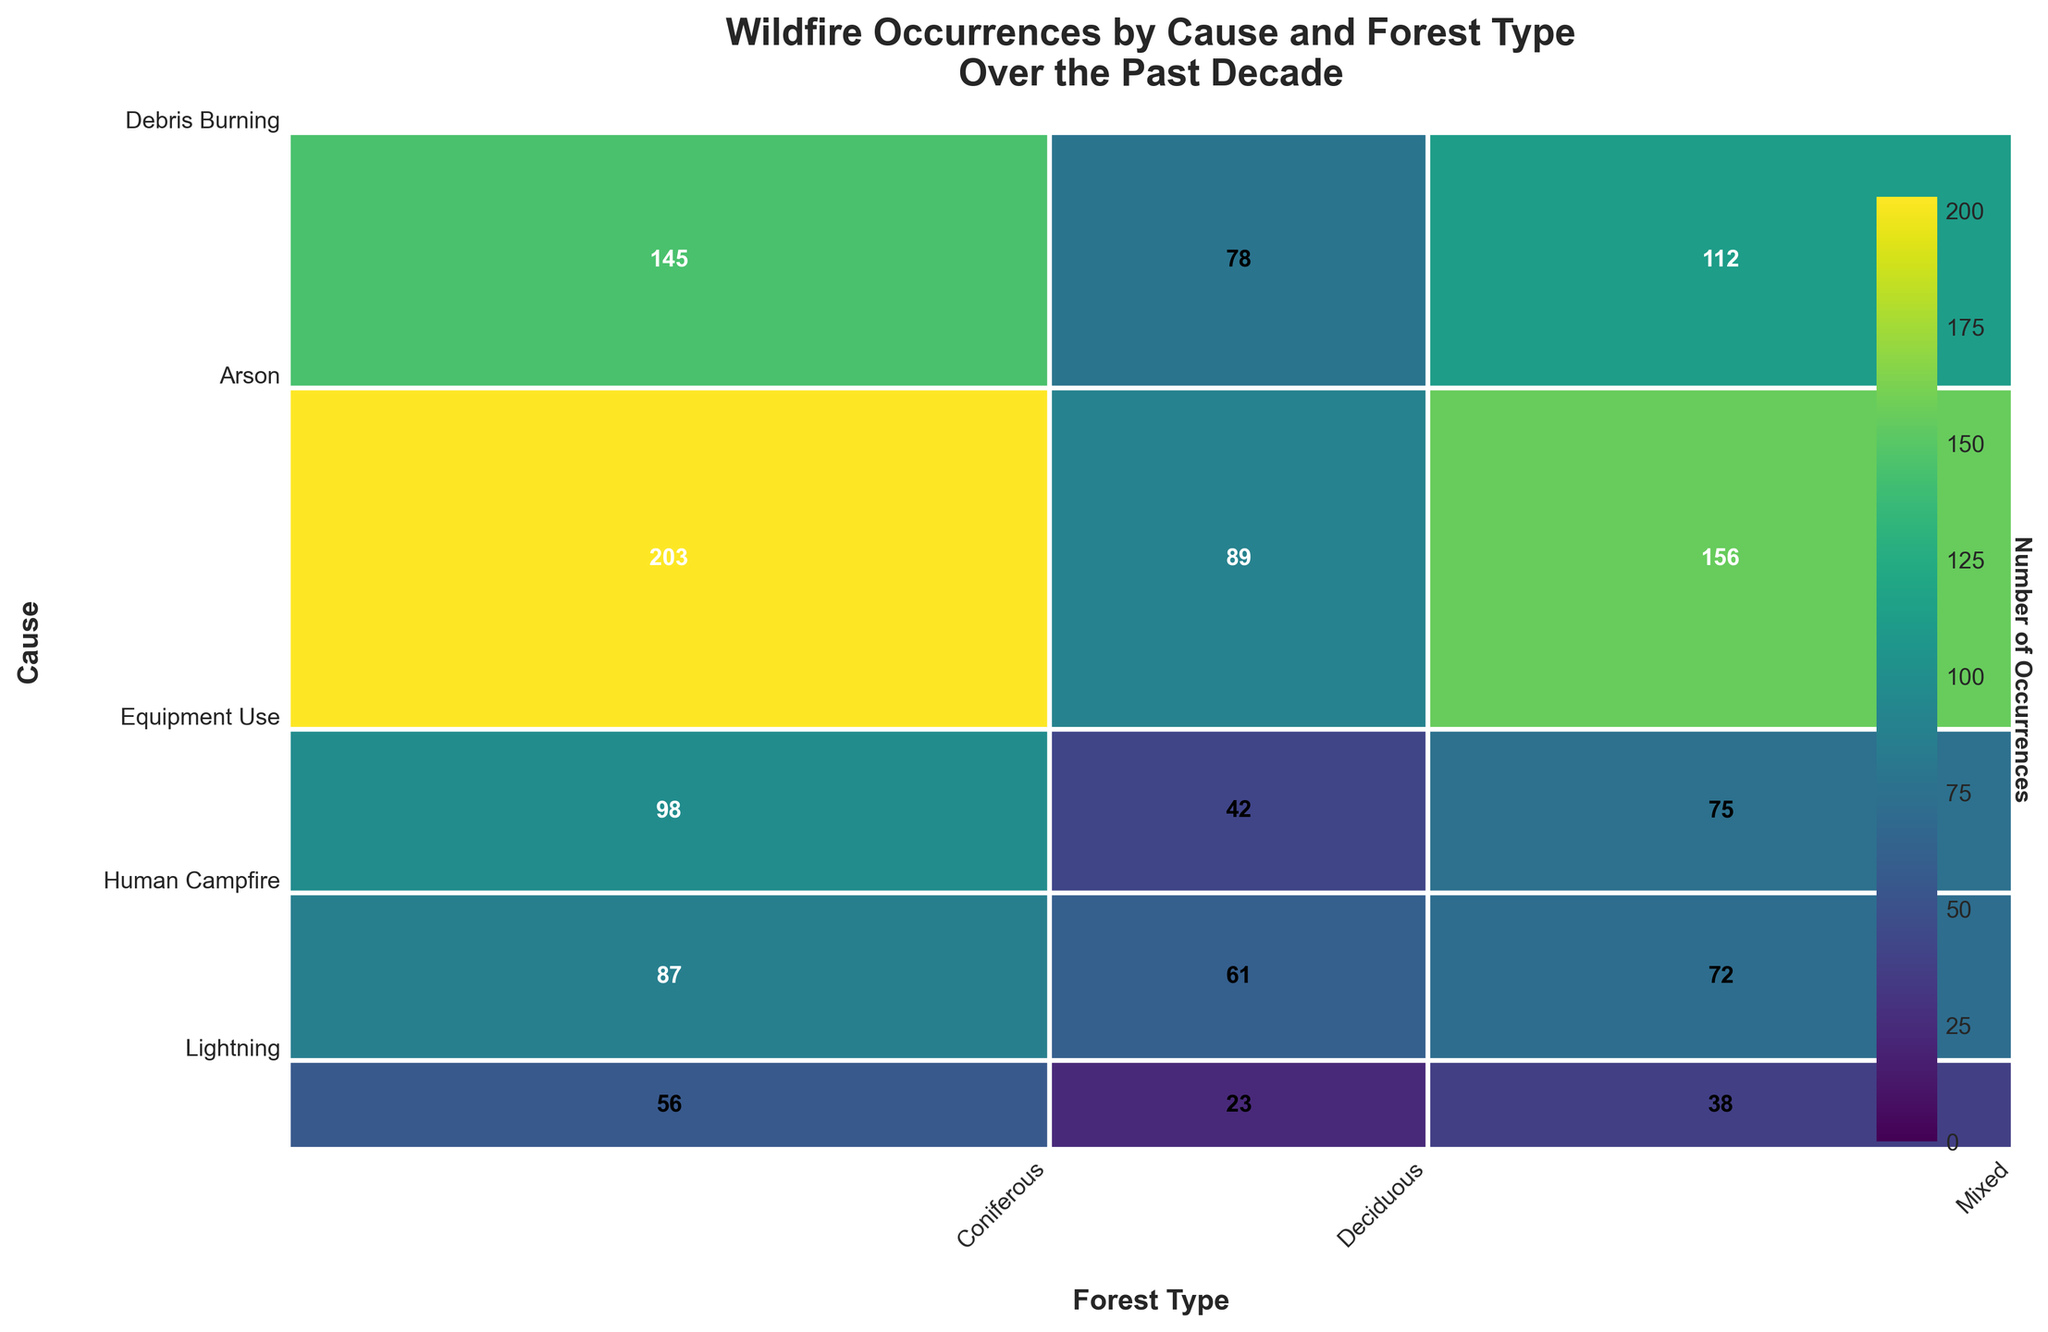Which forest type has the highest number of wildfire occurrences caused by Human Campfires? Look at the section corresponding to Human Campfires on the y-axis and identify which forest type (Coniferous, Deciduous, Mixed) has the largest area. The Coniferous forest type has the highest number of occurrences in this section.
Answer: Coniferous What is the total number of wildfire occurrences in Deciduous forests? Sum the occurrences of all causes (Lightning, Human Campfire, Equipment Use, Arson, Debris Burning) for Deciduous forests. 78 (Lightning) + 89 (Human Campfire) + 42 (Equipment Use) + 23 (Arson) + 61 (Debris Burning) = 293.
Answer: 293 Which wildfire cause has the least occurrences in Mixed forests? Identify the sections corresponding to Mixed forests for each cause on the y-axis and compare their areas. The smallest section corresponds to Arson with 38 occurrences.
Answer: Arson What is the proportion of Equipment Use-caused wildfires in Coniferous forests versus Mixed forests? Calculate the number of Equipment Use-caused wildfires in Coniferous and Mixed forests: 98 in Coniferous, 75 in Mixed. Proportion = 98 / (98 + 75).
Answer: 98 / (98 + 75) How many more wildfire occurrences are there in Coniferous forests due to Human Campfires compared to Debris Burning? Subtract the number of Debris Burning occurrences from Human Campfires in Coniferous forests: 203 (Human Campfire) - 87 (Debris Burning) = 116.
Answer: 116 Which forest type has the greatest total number of wildfires from all causes combined? Sum the occurrences for all forest types across all causes and compare: 
- Coniferous: 145 + 203 + 98 + 56 + 87 = 589
- Deciduous: 78 + 89 + 42 + 23 + 61 = 293
- Mixed: 112 + 156 + 75 + 38 + 72 = 453. Coniferous has the highest total.
Answer: Coniferous What's the average number of wildfires per cause in Mixed forests? Sum the occurrences for each cause in Mixed forests and divide by the number of causes: (Lightning 112 + Human Campfire 156 + Equipment Use 75 + Arson 38 + Debris Burning 72) / 5 = 453 / 5 = 90.6.
Answer: 90.6 What percentage of total wildfires are caused by Lightning in Coniferous forests? Find the total number of wildfires, then calculate the percentage of Lightning-caused in Coniferous forests: 
Total wildfires: 589 (Coniferous) + 293 (Deciduous) + 453 (Mixed) = 1335. 
Percentage = (145 / 1335) * 100 ≈ 10.9%.
Answer: 10.9% Which forest type has the smallest number of wildfires caused by Arson combined? Sum the occurrences of Arson-caused wildfires in all forest types and compare: 
- Coniferous: 56
- Deciduous: 23
- Mixed: 38 
Deciduous has the smallest total with 23 occurrences.
Answer: Deciduous 